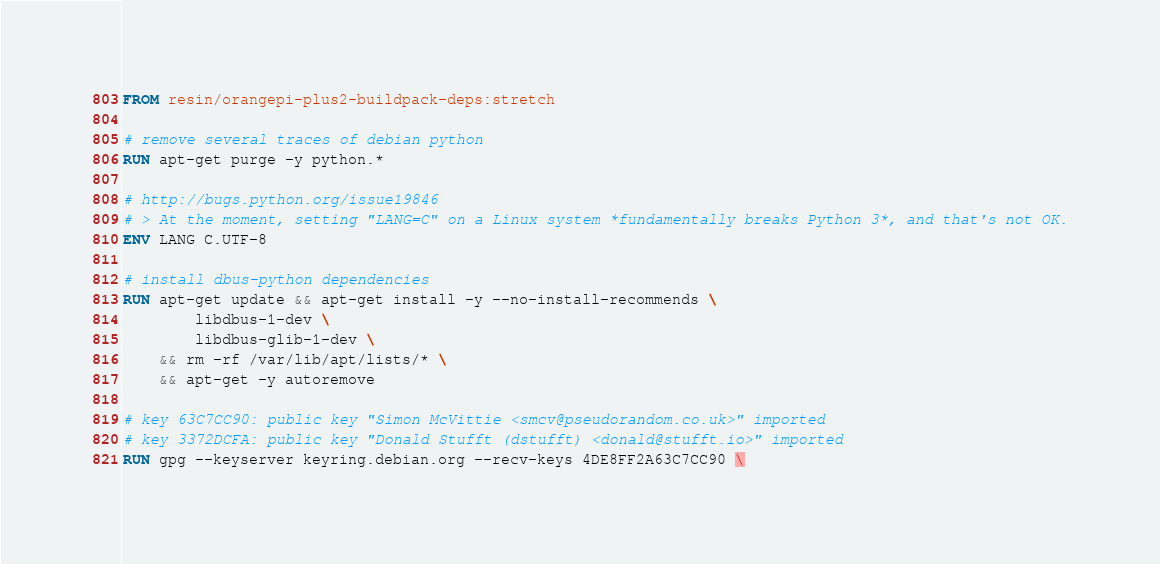<code> <loc_0><loc_0><loc_500><loc_500><_Dockerfile_>FROM resin/orangepi-plus2-buildpack-deps:stretch

# remove several traces of debian python
RUN apt-get purge -y python.*

# http://bugs.python.org/issue19846
# > At the moment, setting "LANG=C" on a Linux system *fundamentally breaks Python 3*, and that's not OK.
ENV LANG C.UTF-8

# install dbus-python dependencies 
RUN apt-get update && apt-get install -y --no-install-recommends \
		libdbus-1-dev \
		libdbus-glib-1-dev \
	&& rm -rf /var/lib/apt/lists/* \
	&& apt-get -y autoremove

# key 63C7CC90: public key "Simon McVittie <smcv@pseudorandom.co.uk>" imported
# key 3372DCFA: public key "Donald Stufft (dstufft) <donald@stufft.io>" imported
RUN gpg --keyserver keyring.debian.org --recv-keys 4DE8FF2A63C7CC90 \</code> 